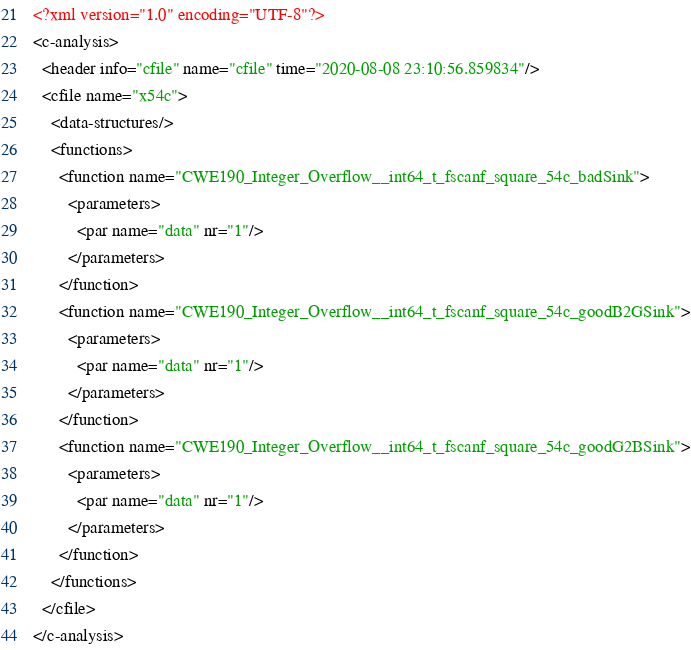<code> <loc_0><loc_0><loc_500><loc_500><_XML_><?xml version="1.0" encoding="UTF-8"?>
<c-analysis>
  <header info="cfile" name="cfile" time="2020-08-08 23:10:56.859834"/>
  <cfile name="x54c">
    <data-structures/>
    <functions>
      <function name="CWE190_Integer_Overflow__int64_t_fscanf_square_54c_badSink">
        <parameters>
          <par name="data" nr="1"/>
        </parameters>
      </function>
      <function name="CWE190_Integer_Overflow__int64_t_fscanf_square_54c_goodB2GSink">
        <parameters>
          <par name="data" nr="1"/>
        </parameters>
      </function>
      <function name="CWE190_Integer_Overflow__int64_t_fscanf_square_54c_goodG2BSink">
        <parameters>
          <par name="data" nr="1"/>
        </parameters>
      </function>
    </functions>
  </cfile>
</c-analysis>
</code> 